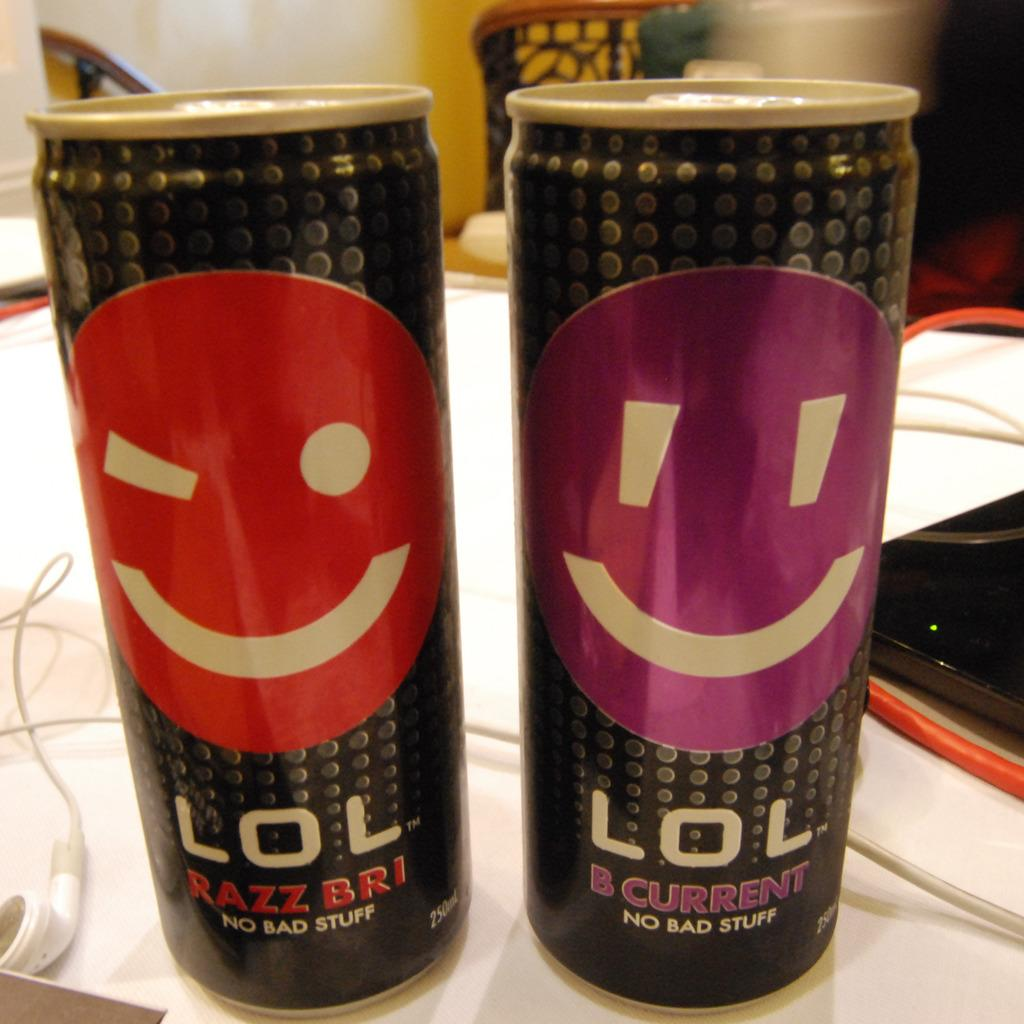<image>
Offer a succinct explanation of the picture presented. Two can of the drink LOL, one B current flavor and one Razz Bri flavor. 